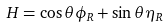Convert formula to latex. <formula><loc_0><loc_0><loc_500><loc_500>H = \cos \theta \phi _ { R } + \sin \theta \eta _ { R }</formula> 